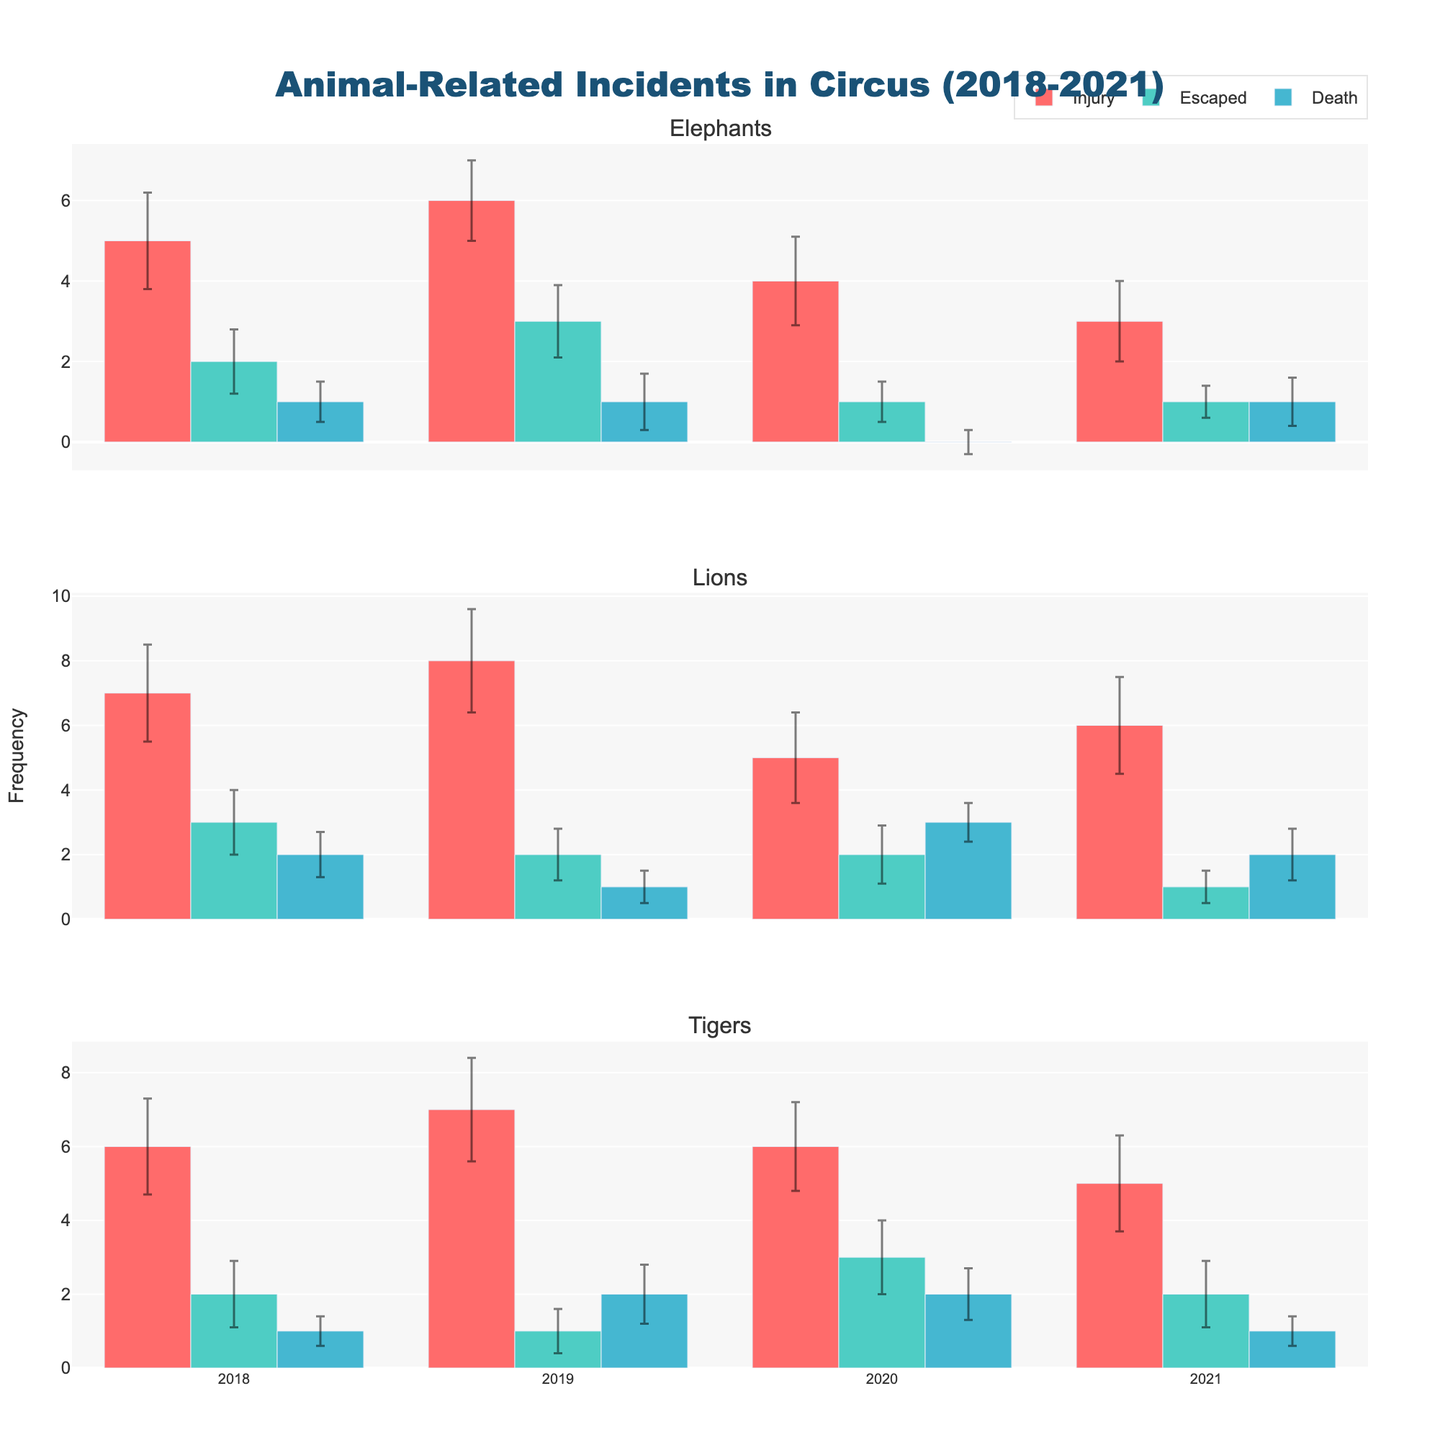How many types of incidents are recorded for each animal type? The figure displays bars for three types of incidents: Injury, Escaped, and Death, across different rows for each animal type (Elephants, Lions, and Tigers).
Answer: Three Which animal had the most injuries in 2021? By looking at the top bars in the 2021 section of each subplot, Lions had the most injuries in 2021, represented by the highest red bar in that year's section.
Answer: Lions What is the frequency range of escapes for Elephants from 2018 to 2021? For Elephants, the escape frequencies are represented by teal bars in their respective rows from 2018 to 2021. The highest frequency is 3 (2019), and the lowest is 1 (2020 and 2021).
Answer: 1 to 3 What was the total number of deaths for all animals in 2021? Add the heights of the blue bars (representing deaths) for Elephants, Lions, and Tigers in 2021: 1 (Elephants) + 2 (Lions) + 1 (Tigers) = 4.
Answer: 4 Which animal had the greatest standard deviation in injury frequency in 2020? Examine the error bars (the vertical lines) for each animal's injury frequency in 2020. Lions had the largest standard deviation as their error bar was the longest.
Answer: Lions How did the number of Tiger escapes change from 2019 to 2020? Locate the teal bars for Tigers in 2019 and 2020. The frequency of escapes increased from 1 in 2019 to 3 in 2020.
Answer: Increased Which year had the highest number of incidents for Lions? Compare the total heights of all colors representing different incident types for Lions across all years. 2018 (7 injuries, 3 escapes, 2 deaths) sums up to the highest total of 12 incidents.
Answer: 2018 What was the most frequent type of incident for Tigers in 2021? Look at the bars for Tigers in 2021; the red bar (Injuries) is the highest, indicating it was the most frequent type of incident.
Answer: Injury For which incident type did Elephants' frequency show the greatest decrease from 2019 to 2020? Compare bars for Elephants between 2019 and 2020. The most significant decrease was in injuries, which decreased from 6 (2019) to 4 (2020).
Answer: Injury What is the average number of deaths per year for Lions between 2018-2021? Identify and sum the blue bars for Lions across all years and divide by the number of years: (2 + 1 + 3 + 2) / 4 = 2.
Answer: 2 